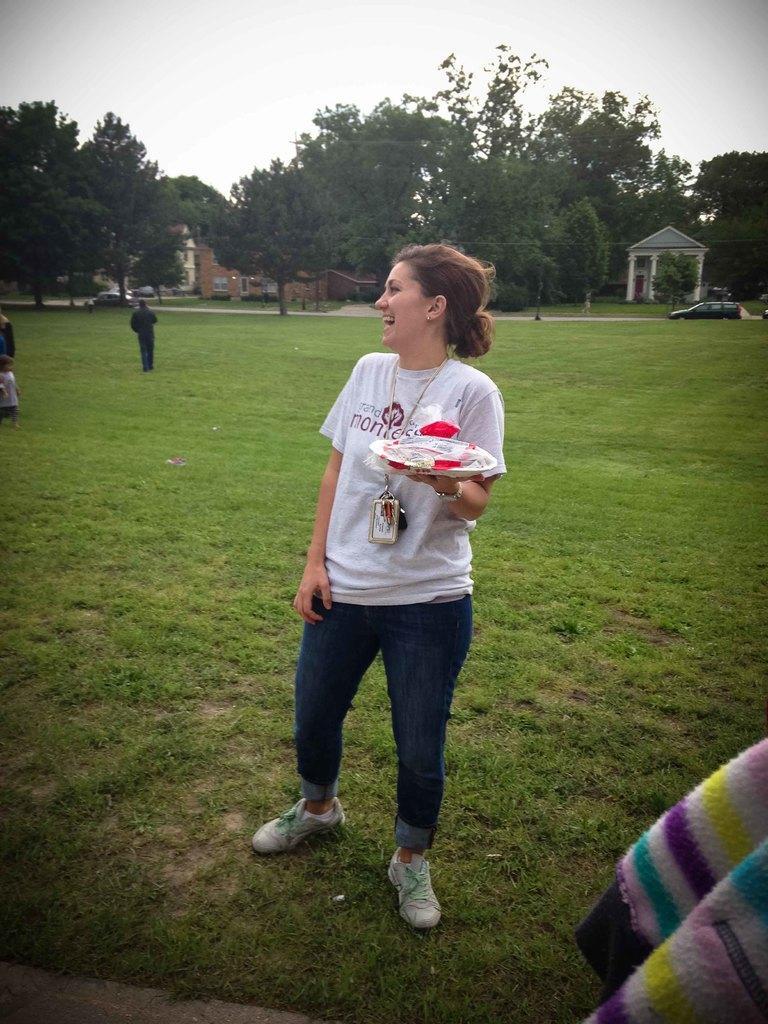In one or two sentences, can you explain what this image depicts? This image consists of a woman wearing a white T-shirt. She is holding a plate. At the bottom, there is green grass on the ground. On the left, we can see three persons. In the background, we can see buildings and trees. At the top, there is sky. In the middle, there are cars. On the right, we can see a cloth, which looks like a sweater. 